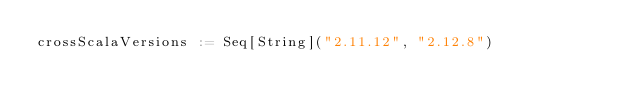<code> <loc_0><loc_0><loc_500><loc_500><_Scala_>crossScalaVersions := Seq[String]("2.11.12", "2.12.8")
</code> 